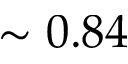Convert formula to latex. <formula><loc_0><loc_0><loc_500><loc_500>\sim 0 . 8 4</formula> 